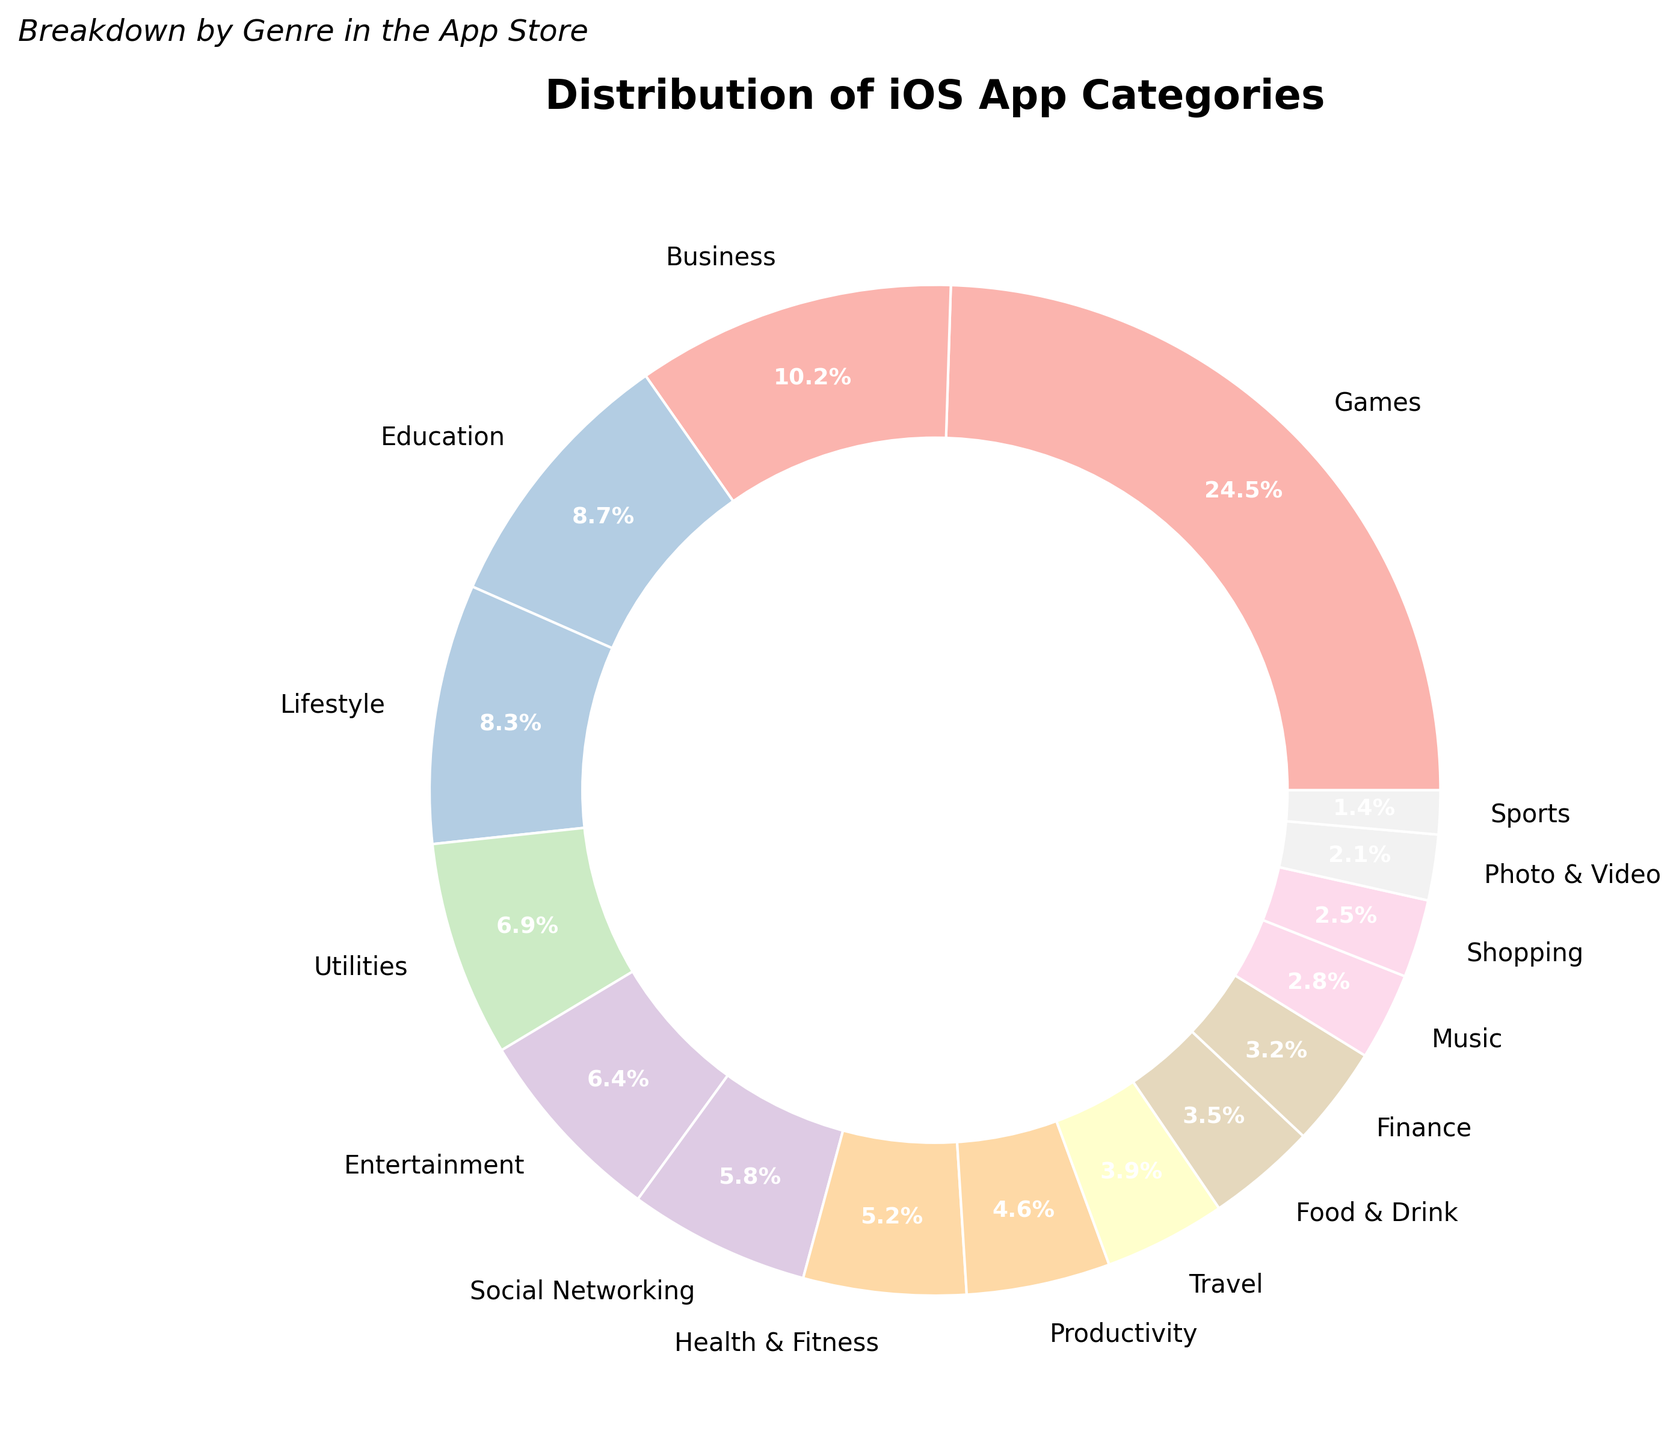What category holds the largest percentage of iOS apps in the App Store? Identify the slice of the pie chart with the largest area. Its label is "Games" and the percentage is 24.5%
Answer: Games Which iOS app categories combined have higher than 20% of the total apps? Identify the categories with percentages above 20% and list them. Only "Games" has 24.5%, so it stands alone above 20%
Answer: Games Which category represents approximately double the percentage of Photo & Video? Identify the percentage of "Photo & Video" (2.1%) and find the category around double that value, which is close to 4.2%. "Productivity" (4.6%) is the nearest to double
Answer: Productivity 